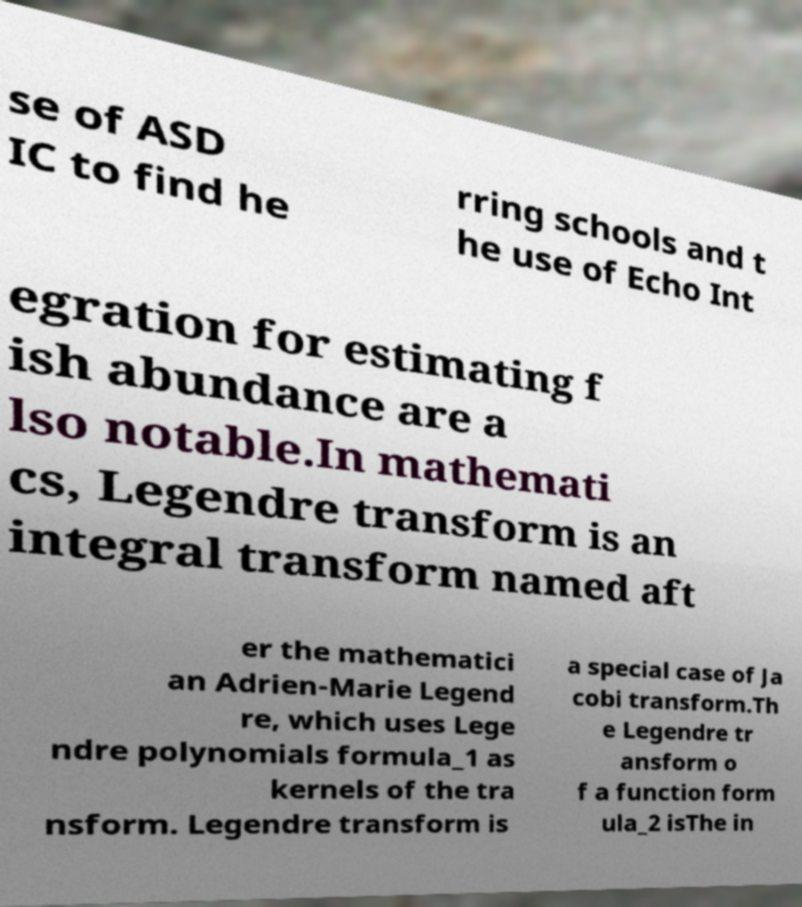There's text embedded in this image that I need extracted. Can you transcribe it verbatim? se of ASD IC to find he rring schools and t he use of Echo Int egration for estimating f ish abundance are a lso notable.In mathemati cs, Legendre transform is an integral transform named aft er the mathematici an Adrien-Marie Legend re, which uses Lege ndre polynomials formula_1 as kernels of the tra nsform. Legendre transform is a special case of Ja cobi transform.Th e Legendre tr ansform o f a function form ula_2 isThe in 